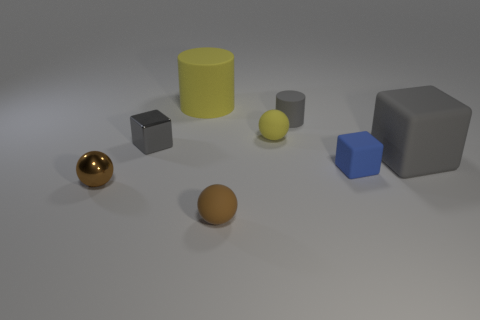Subtract all gray blocks. How many blocks are left? 1 Subtract 1 spheres. How many spheres are left? 2 Add 1 large things. How many objects exist? 9 Subtract all cubes. How many objects are left? 5 Add 7 red metal balls. How many red metal balls exist? 7 Subtract 1 yellow spheres. How many objects are left? 7 Subtract all large things. Subtract all small yellow rubber things. How many objects are left? 5 Add 4 large rubber cubes. How many large rubber cubes are left? 5 